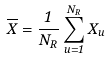<formula> <loc_0><loc_0><loc_500><loc_500>\overline { X } = \frac { 1 } { N _ { R } } \sum _ { u = 1 } ^ { N _ { R } } X _ { u }</formula> 